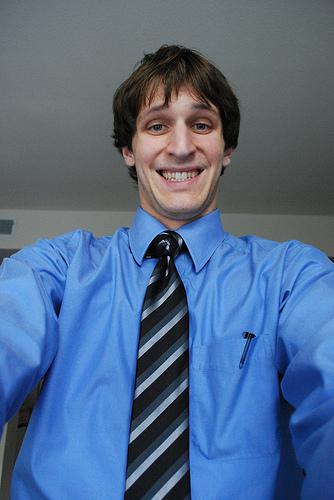Question: what is he wearing?
Choices:
A. Tie.
B. Hat.
C. Watch.
D. Shoes.
Answer with the letter. Answer: A Question: what color is his shirt?
Choices:
A. Brown.
B. Blue.
C. Black.
D. Purple.
Answer with the letter. Answer: B Question: what is above him?
Choices:
A. Light.
B. Umbrella.
C. Tree.
D. Ceiling.
Answer with the letter. Answer: D 